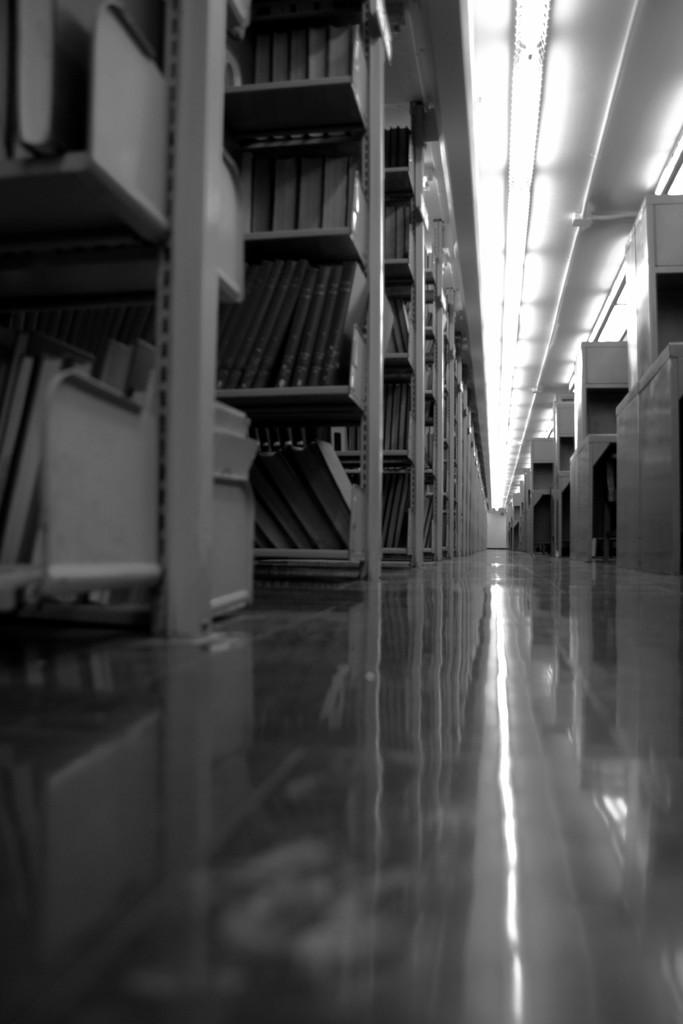What is the color scheme of the image? The image is black and white. What objects are present in the image? There is a group of books in the image. How are the books arranged in the image? The books are placed in racks. What architectural feature is visible in the image? There is a roof visible in the image. What type of lighting is present in the image? There are ceiling lights on the roof. Is there a volleyball game happening in the image? No, there is no volleyball game present in the image. What direction is the rain falling in the image? There is no rain present in the image. 